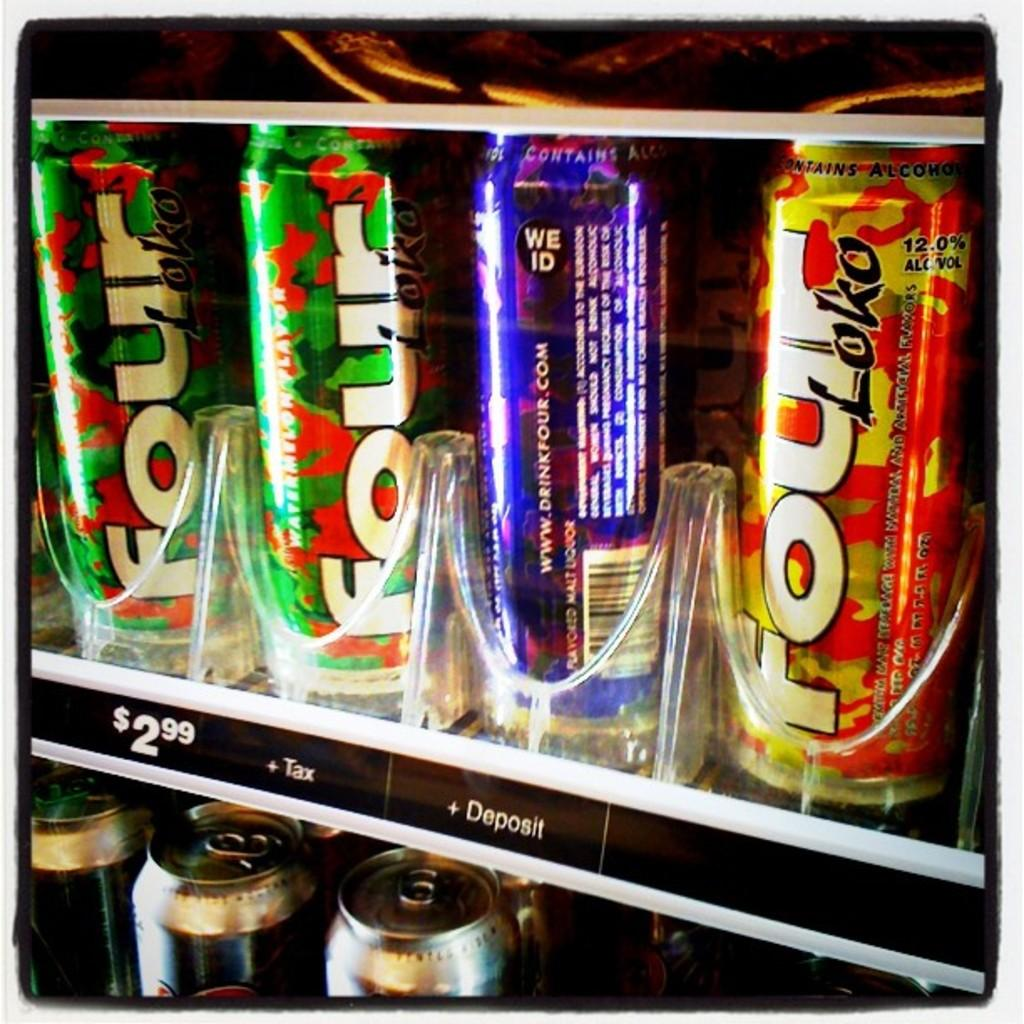Provide a one-sentence caption for the provided image. Bottles inside a vending machine with one saying Loko on it. 